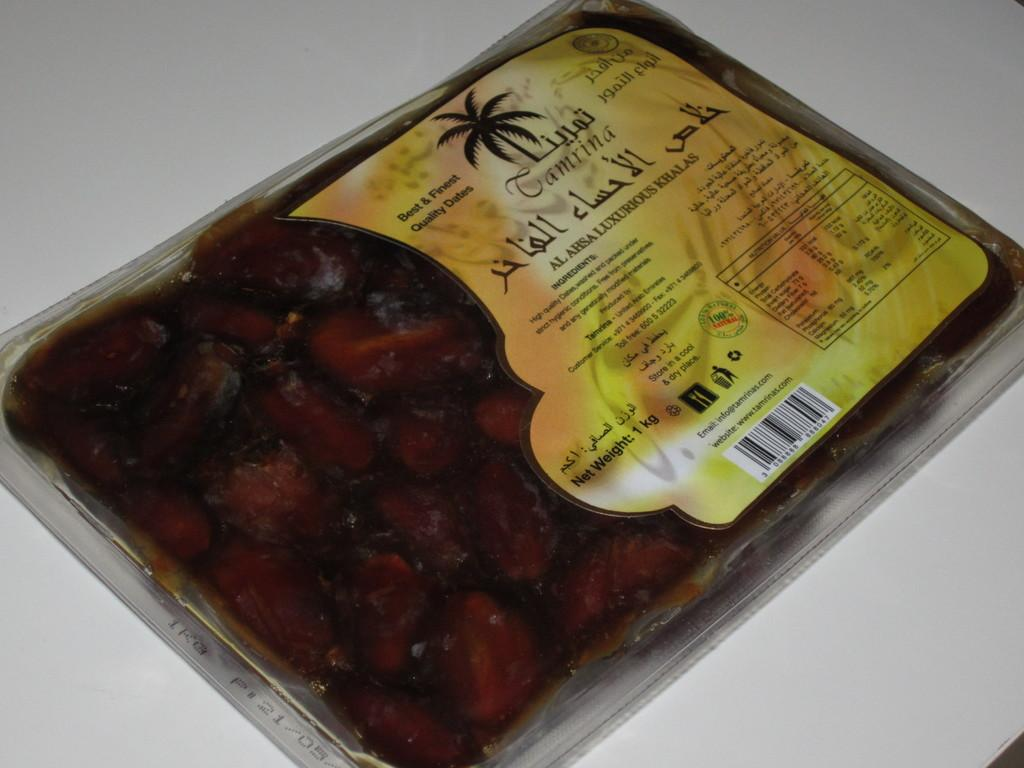What is the main subject of the image? The main subject of the image is a food item wrapped in a cover. How can we identify the food item in the image? There is a tag on the food item, which may provide information about its contents or origin. What is the background or surface in the image? There is a white surface in the image. What type of park is visible in the image? There is no park present in the image; it features a food item wrapped in a cover with a tag on a white surface. 